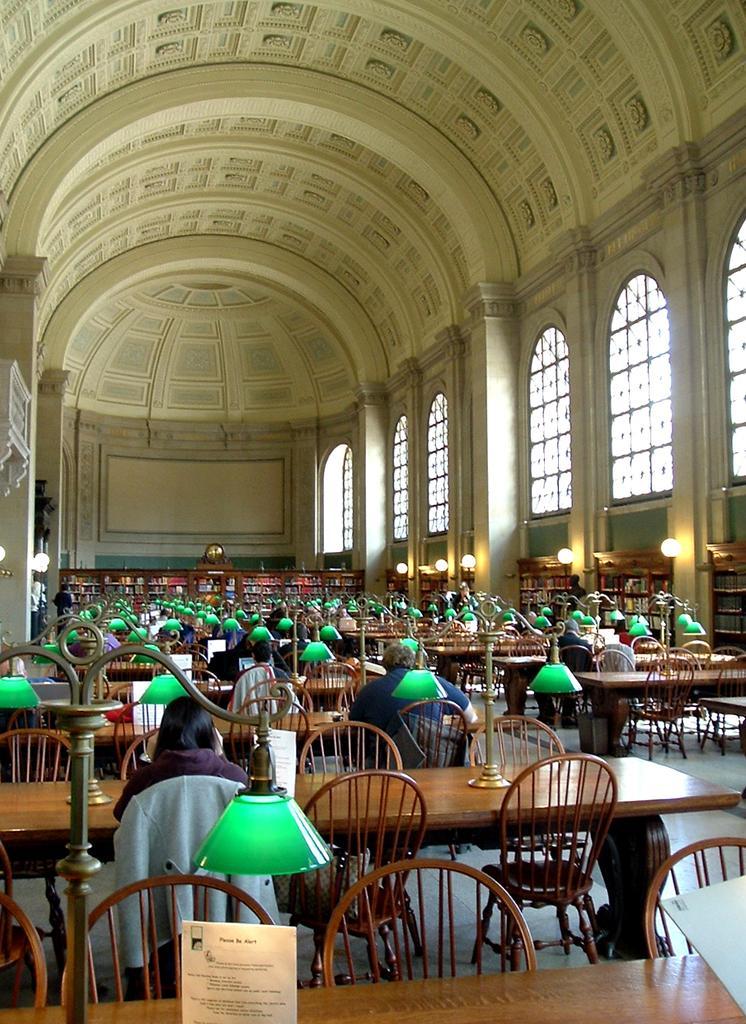Please provide a concise description of this image. In this picture we can see a group of people sitting on chairs and in front of them we can see tables with lamp stands on it and in the background we can see windows. 